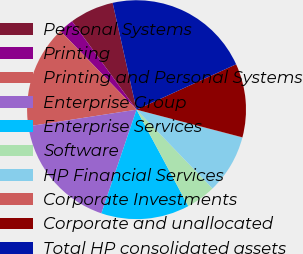Convert chart. <chart><loc_0><loc_0><loc_500><loc_500><pie_chart><fcel>Personal Systems<fcel>Printing<fcel>Printing and Personal Systems<fcel>Enterprise Group<fcel>Enterprise Services<fcel>Software<fcel>HP Financial Services<fcel>Corporate Investments<fcel>Corporate and unallocated<fcel>Total HP consolidated assets<nl><fcel>6.53%<fcel>2.2%<fcel>15.2%<fcel>17.37%<fcel>13.04%<fcel>4.37%<fcel>8.7%<fcel>0.03%<fcel>10.87%<fcel>21.7%<nl></chart> 